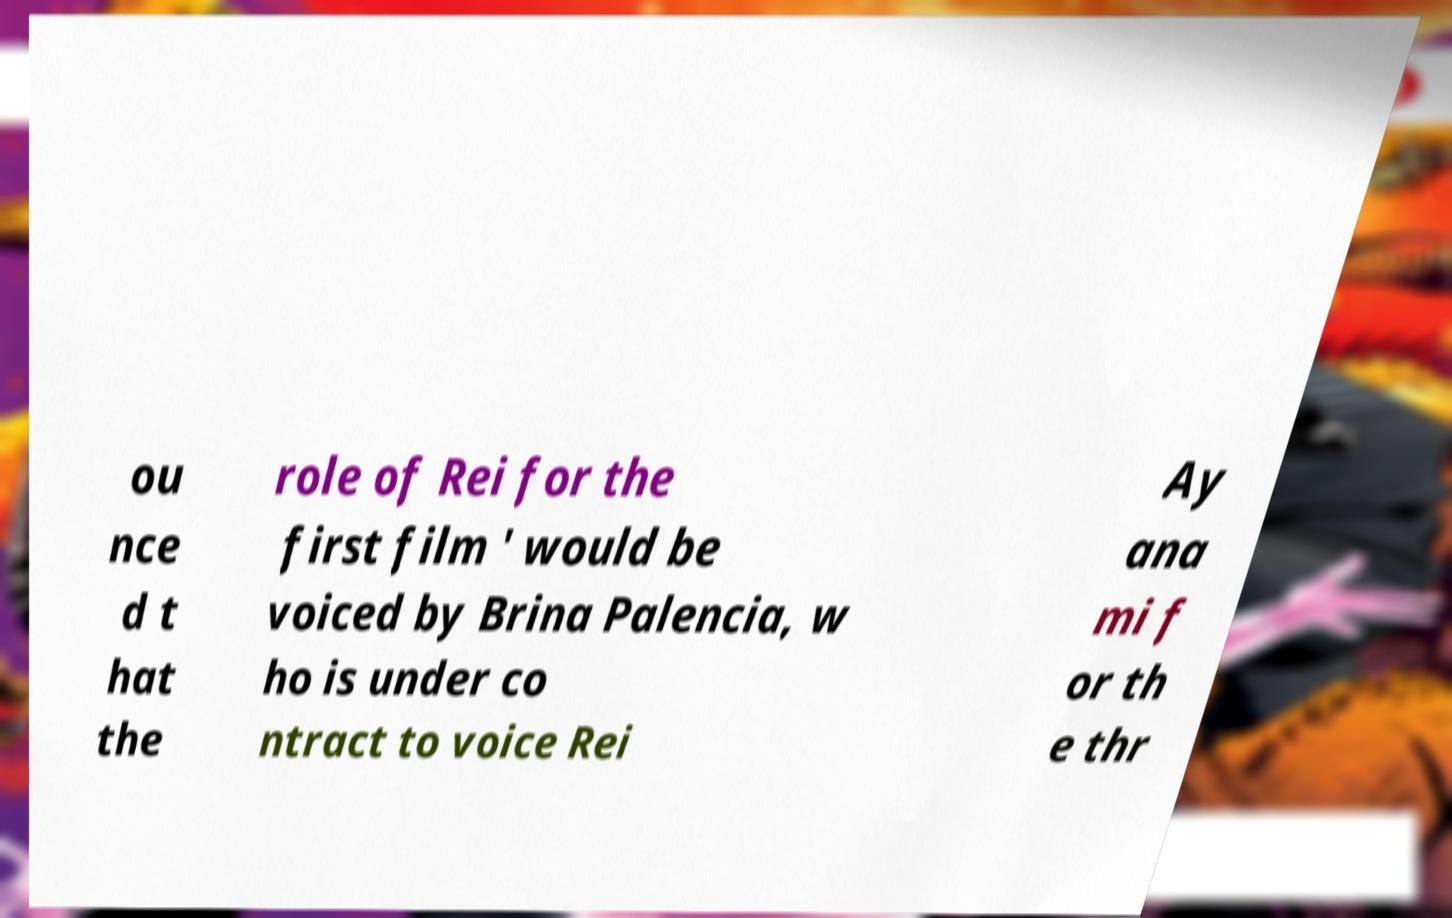What messages or text are displayed in this image? I need them in a readable, typed format. ou nce d t hat the role of Rei for the first film ' would be voiced by Brina Palencia, w ho is under co ntract to voice Rei Ay ana mi f or th e thr 